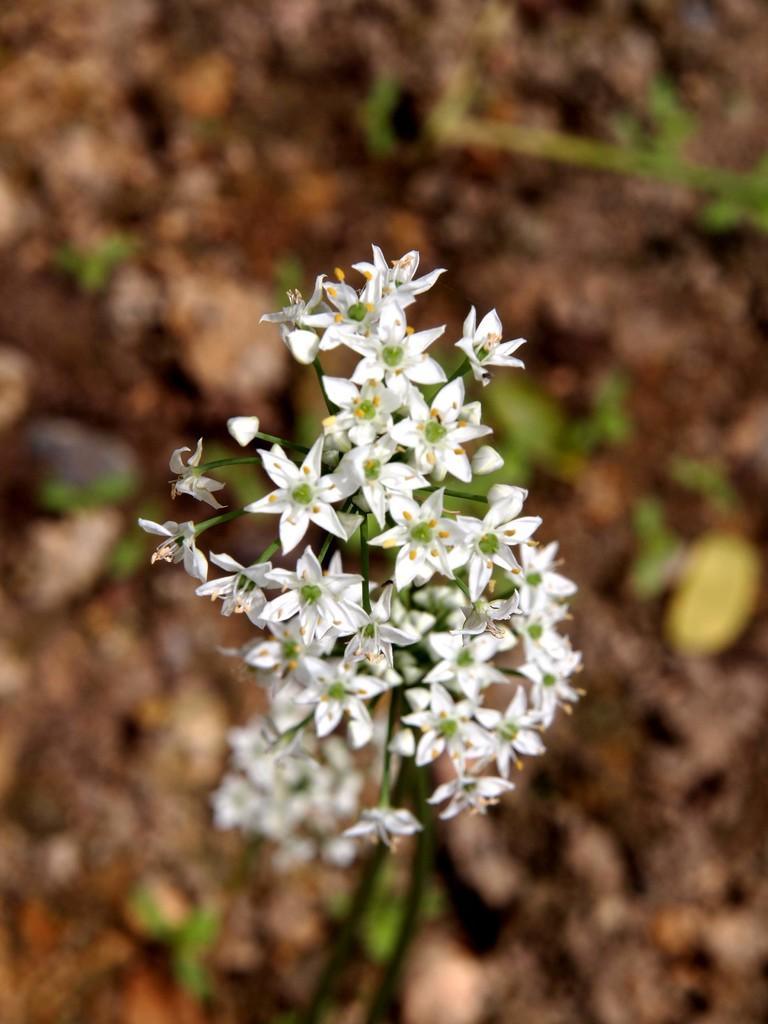Can you describe this image briefly? In this picture I can see many white flowers on the plant or grass. On the right it might be the yellow flower. 